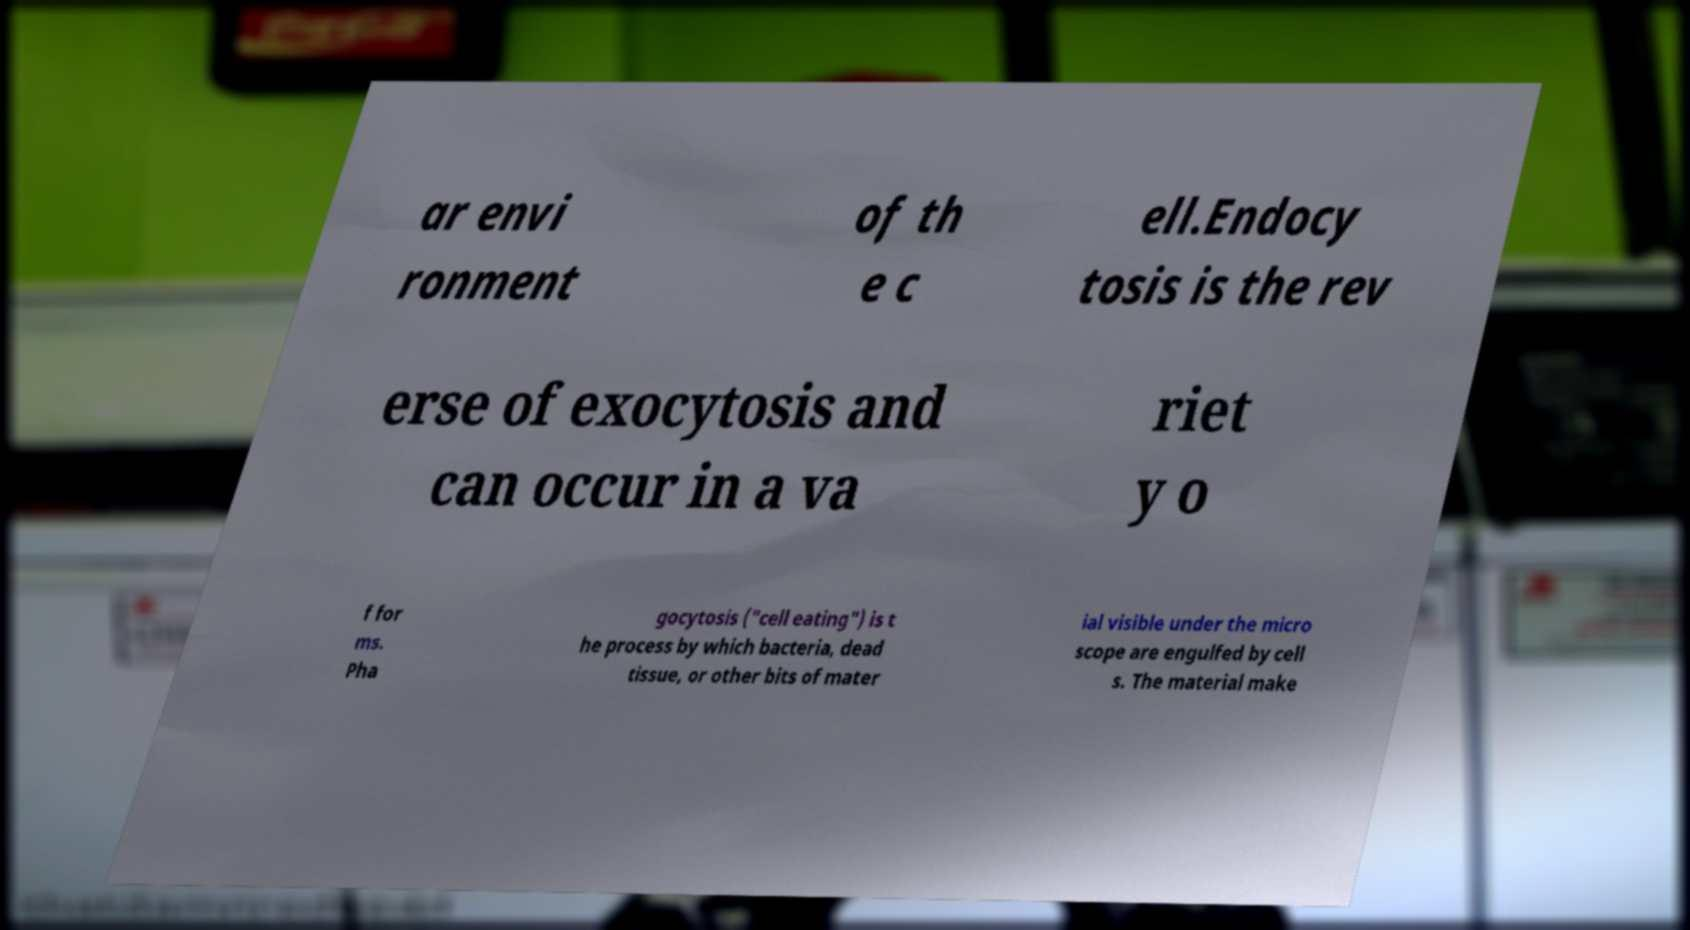I need the written content from this picture converted into text. Can you do that? ar envi ronment of th e c ell.Endocy tosis is the rev erse of exocytosis and can occur in a va riet y o f for ms. Pha gocytosis ("cell eating") is t he process by which bacteria, dead tissue, or other bits of mater ial visible under the micro scope are engulfed by cell s. The material make 